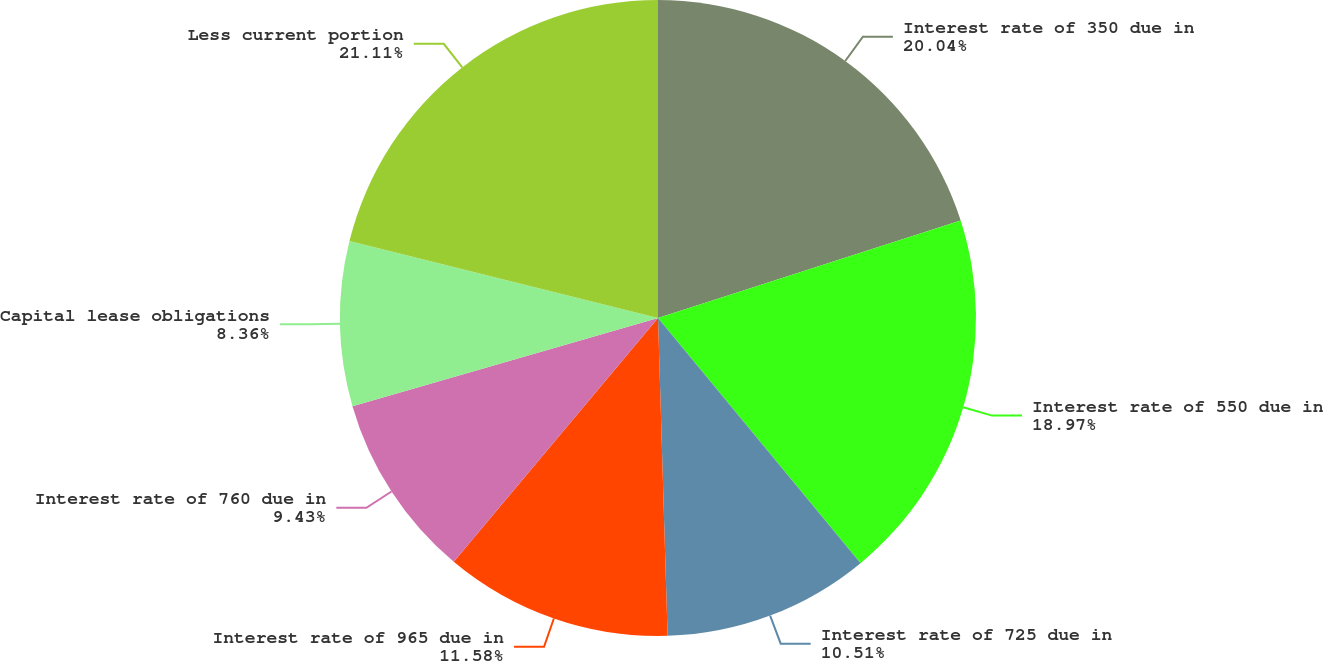<chart> <loc_0><loc_0><loc_500><loc_500><pie_chart><fcel>Interest rate of 350 due in<fcel>Interest rate of 550 due in<fcel>Interest rate of 725 due in<fcel>Interest rate of 965 due in<fcel>Interest rate of 760 due in<fcel>Capital lease obligations<fcel>Less current portion<nl><fcel>20.04%<fcel>18.97%<fcel>10.51%<fcel>11.58%<fcel>9.43%<fcel>8.36%<fcel>21.11%<nl></chart> 